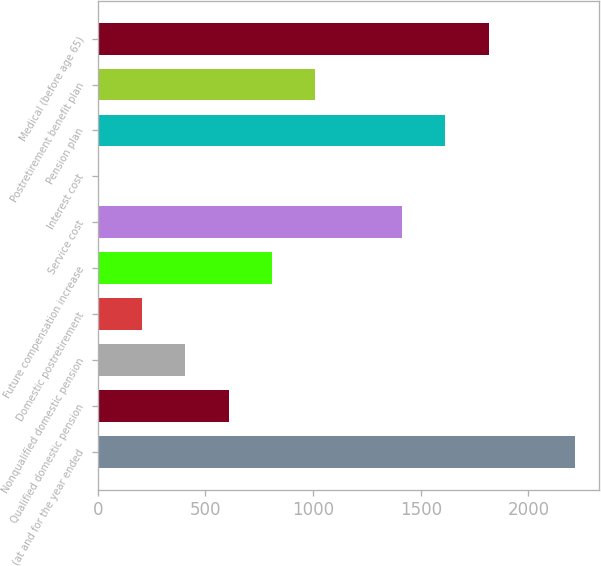<chart> <loc_0><loc_0><loc_500><loc_500><bar_chart><fcel>(at and for the year ended<fcel>Qualified domestic pension<fcel>Nonqualified domestic pension<fcel>Domestic postretirement<fcel>Future compensation increase<fcel>Service cost<fcel>Interest cost<fcel>Pension plan<fcel>Postretirement benefit plan<fcel>Medical (before age 65)<nl><fcel>2218.38<fcel>607.6<fcel>406.25<fcel>204.9<fcel>808.95<fcel>1412.99<fcel>3.55<fcel>1614.34<fcel>1010.3<fcel>1815.68<nl></chart> 